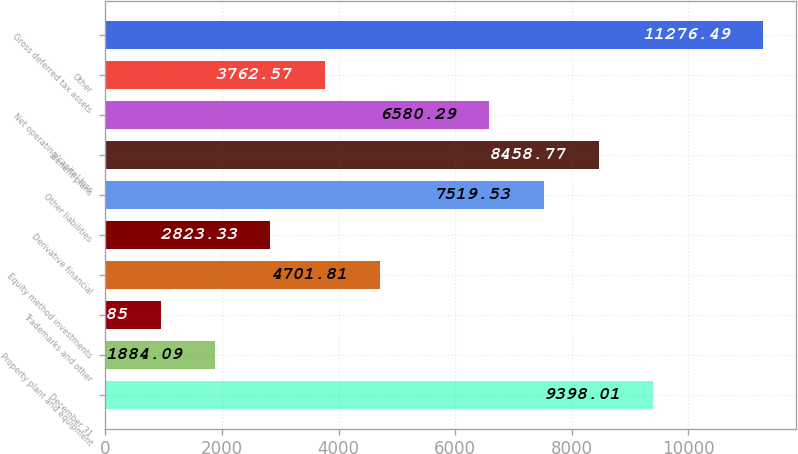Convert chart. <chart><loc_0><loc_0><loc_500><loc_500><bar_chart><fcel>December 31<fcel>Property plant and equipment<fcel>Trademarks and other<fcel>Equity method investments<fcel>Derivative financial<fcel>Other liabilities<fcel>Benefit plans<fcel>Net operating/capital loss<fcel>Other<fcel>Gross deferred tax assets<nl><fcel>9398.01<fcel>1884.09<fcel>944.85<fcel>4701.81<fcel>2823.33<fcel>7519.53<fcel>8458.77<fcel>6580.29<fcel>3762.57<fcel>11276.5<nl></chart> 